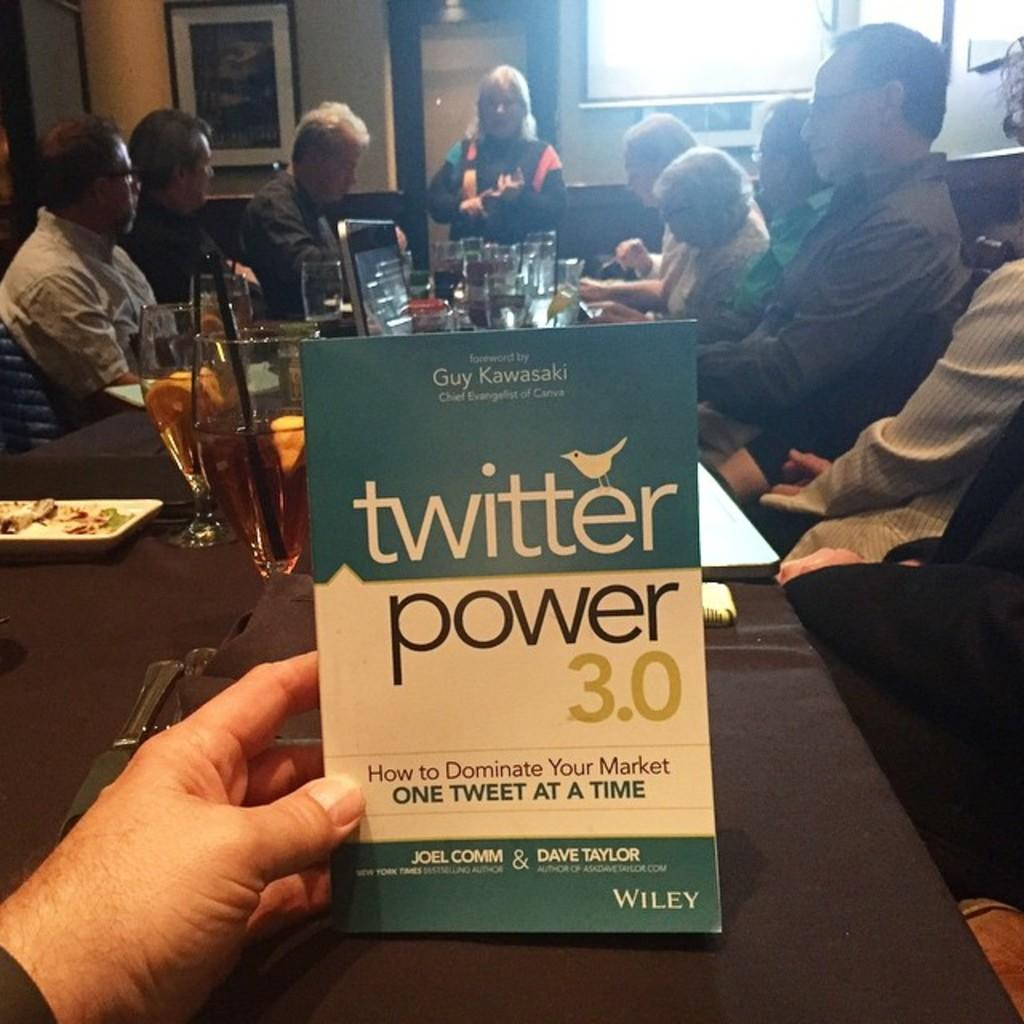<image>
Present a compact description of the photo's key features. Someone holds up a blue twitter power flier next to a table full of people. 